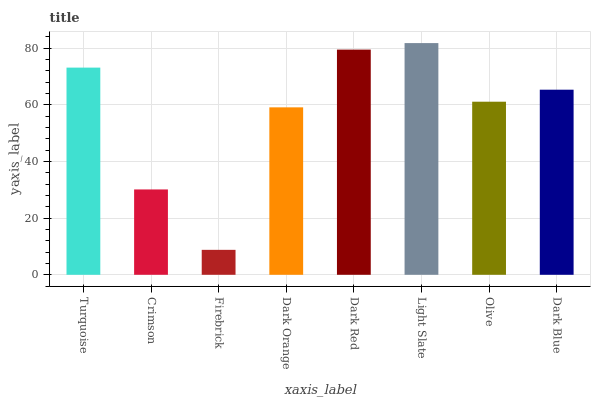Is Crimson the minimum?
Answer yes or no. No. Is Crimson the maximum?
Answer yes or no. No. Is Turquoise greater than Crimson?
Answer yes or no. Yes. Is Crimson less than Turquoise?
Answer yes or no. Yes. Is Crimson greater than Turquoise?
Answer yes or no. No. Is Turquoise less than Crimson?
Answer yes or no. No. Is Dark Blue the high median?
Answer yes or no. Yes. Is Olive the low median?
Answer yes or no. Yes. Is Firebrick the high median?
Answer yes or no. No. Is Turquoise the low median?
Answer yes or no. No. 